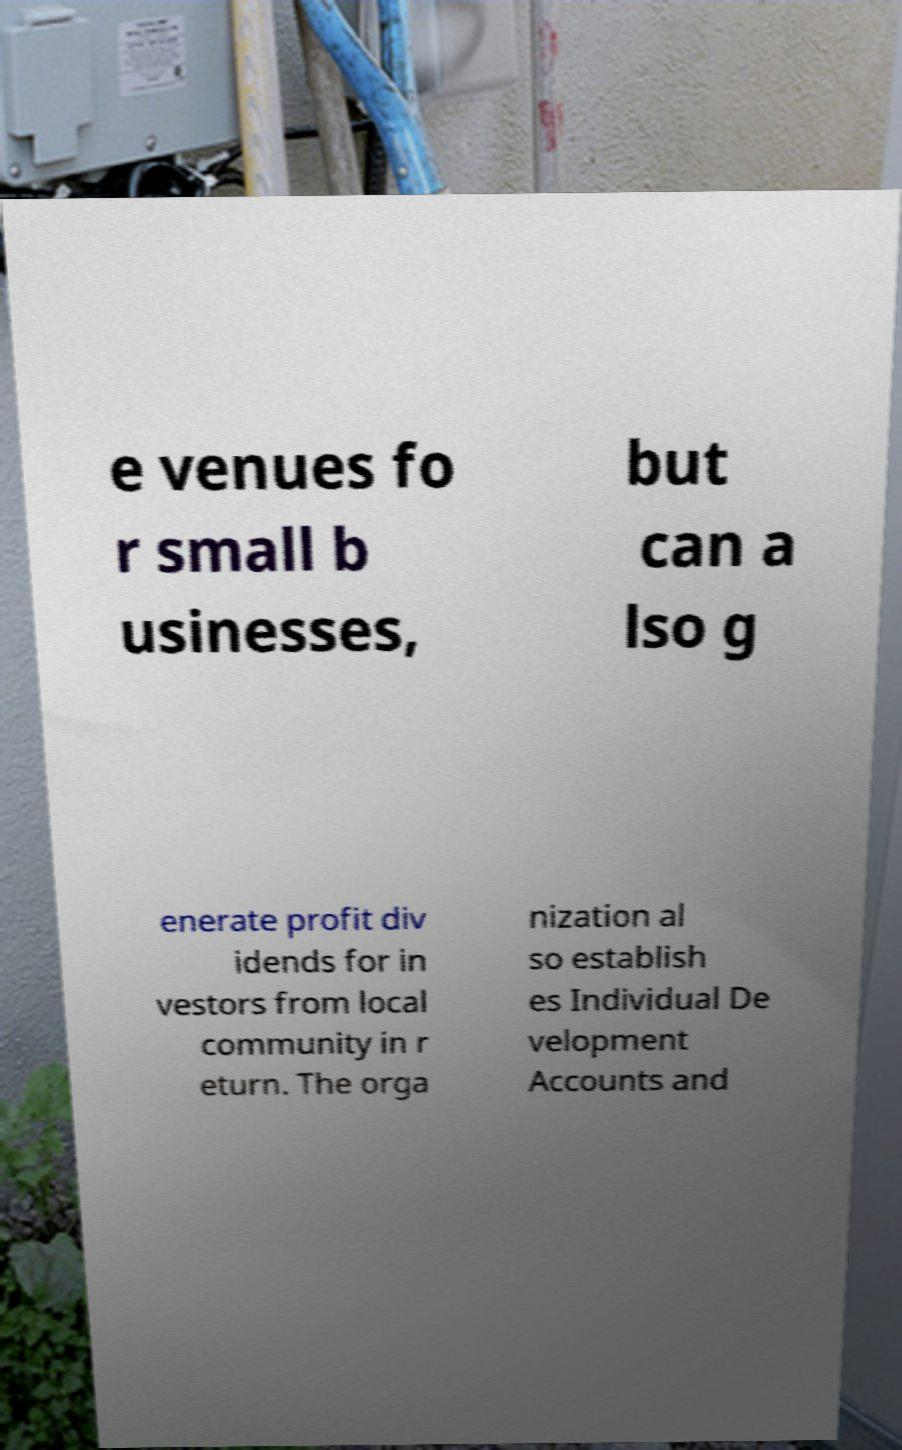Could you extract and type out the text from this image? e venues fo r small b usinesses, but can a lso g enerate profit div idends for in vestors from local community in r eturn. The orga nization al so establish es Individual De velopment Accounts and 